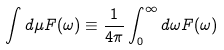<formula> <loc_0><loc_0><loc_500><loc_500>\int d \mu F ( \omega ) \equiv \frac { 1 } { 4 \pi } \int _ { 0 } ^ { \infty } d \omega F ( \omega )</formula> 